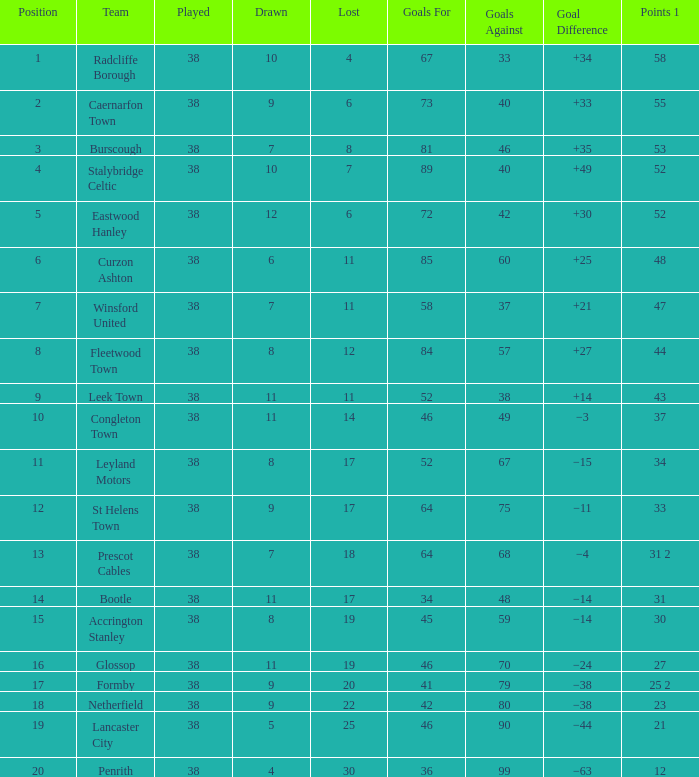WHAT IS THE LOST WITH A DRAWN 11, FOR LEEK TOWN? 11.0. 